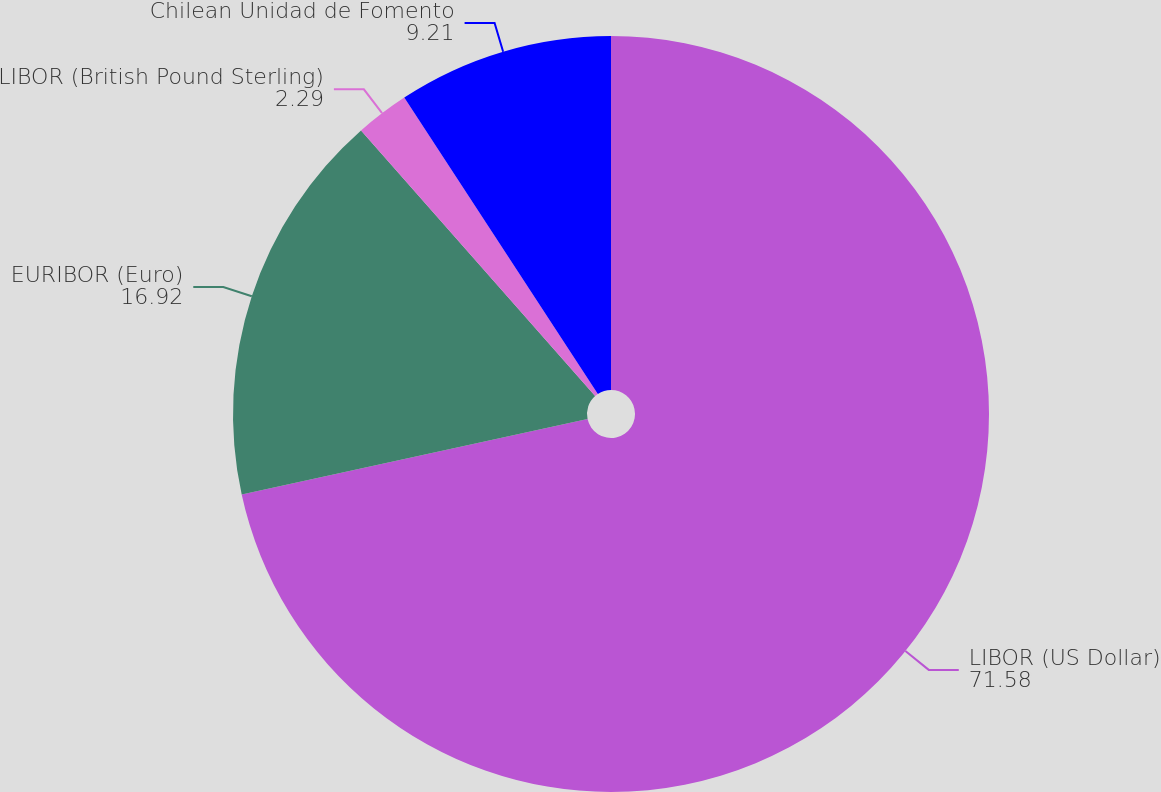Convert chart to OTSL. <chart><loc_0><loc_0><loc_500><loc_500><pie_chart><fcel>LIBOR (US Dollar)<fcel>EURIBOR (Euro)<fcel>LIBOR (British Pound Sterling)<fcel>Chilean Unidad de Fomento<nl><fcel>71.58%<fcel>16.92%<fcel>2.29%<fcel>9.21%<nl></chart> 